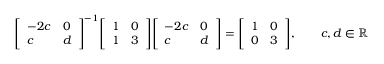<formula> <loc_0><loc_0><loc_500><loc_500>{ \left [ \begin{array} { l l } { - 2 c } & { 0 } \\ { c } & { d } \end{array} \right ] } ^ { - 1 } { \left [ \begin{array} { l l } { 1 } & { 0 } \\ { 1 } & { 3 } \end{array} \right ] } { \left [ \begin{array} { l l } { - 2 c } & { 0 } \\ { c } & { d } \end{array} \right ] } = { \left [ \begin{array} { l l } { 1 } & { 0 } \\ { 0 } & { 3 } \end{array} \right ] } , \quad c , d \in \mathbb { R }</formula> 